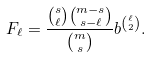<formula> <loc_0><loc_0><loc_500><loc_500>F _ { \ell } = \frac { \binom { s } { \ell } \binom { m - s } { s - \ell } } { \binom { m } { s } } b ^ { \binom { \ell } { 2 } } .</formula> 